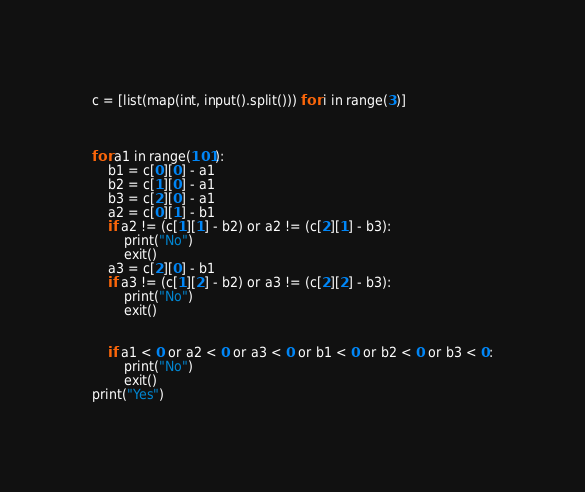<code> <loc_0><loc_0><loc_500><loc_500><_Python_>c = [list(map(int, input().split())) for i in range(3)]



for a1 in range(101):
    b1 = c[0][0] - a1
    b2 = c[1][0] - a1
    b3 = c[2][0] - a1
    a2 = c[0][1] - b1
    if a2 != (c[1][1] - b2) or a2 != (c[2][1] - b3):
        print("No")
        exit()
    a3 = c[2][0] - b1
    if a3 != (c[1][2] - b2) or a3 != (c[2][2] - b3):
        print("No")
        exit()


    if a1 < 0 or a2 < 0 or a3 < 0 or b1 < 0 or b2 < 0 or b3 < 0:
        print("No")
        exit()
print("Yes")</code> 